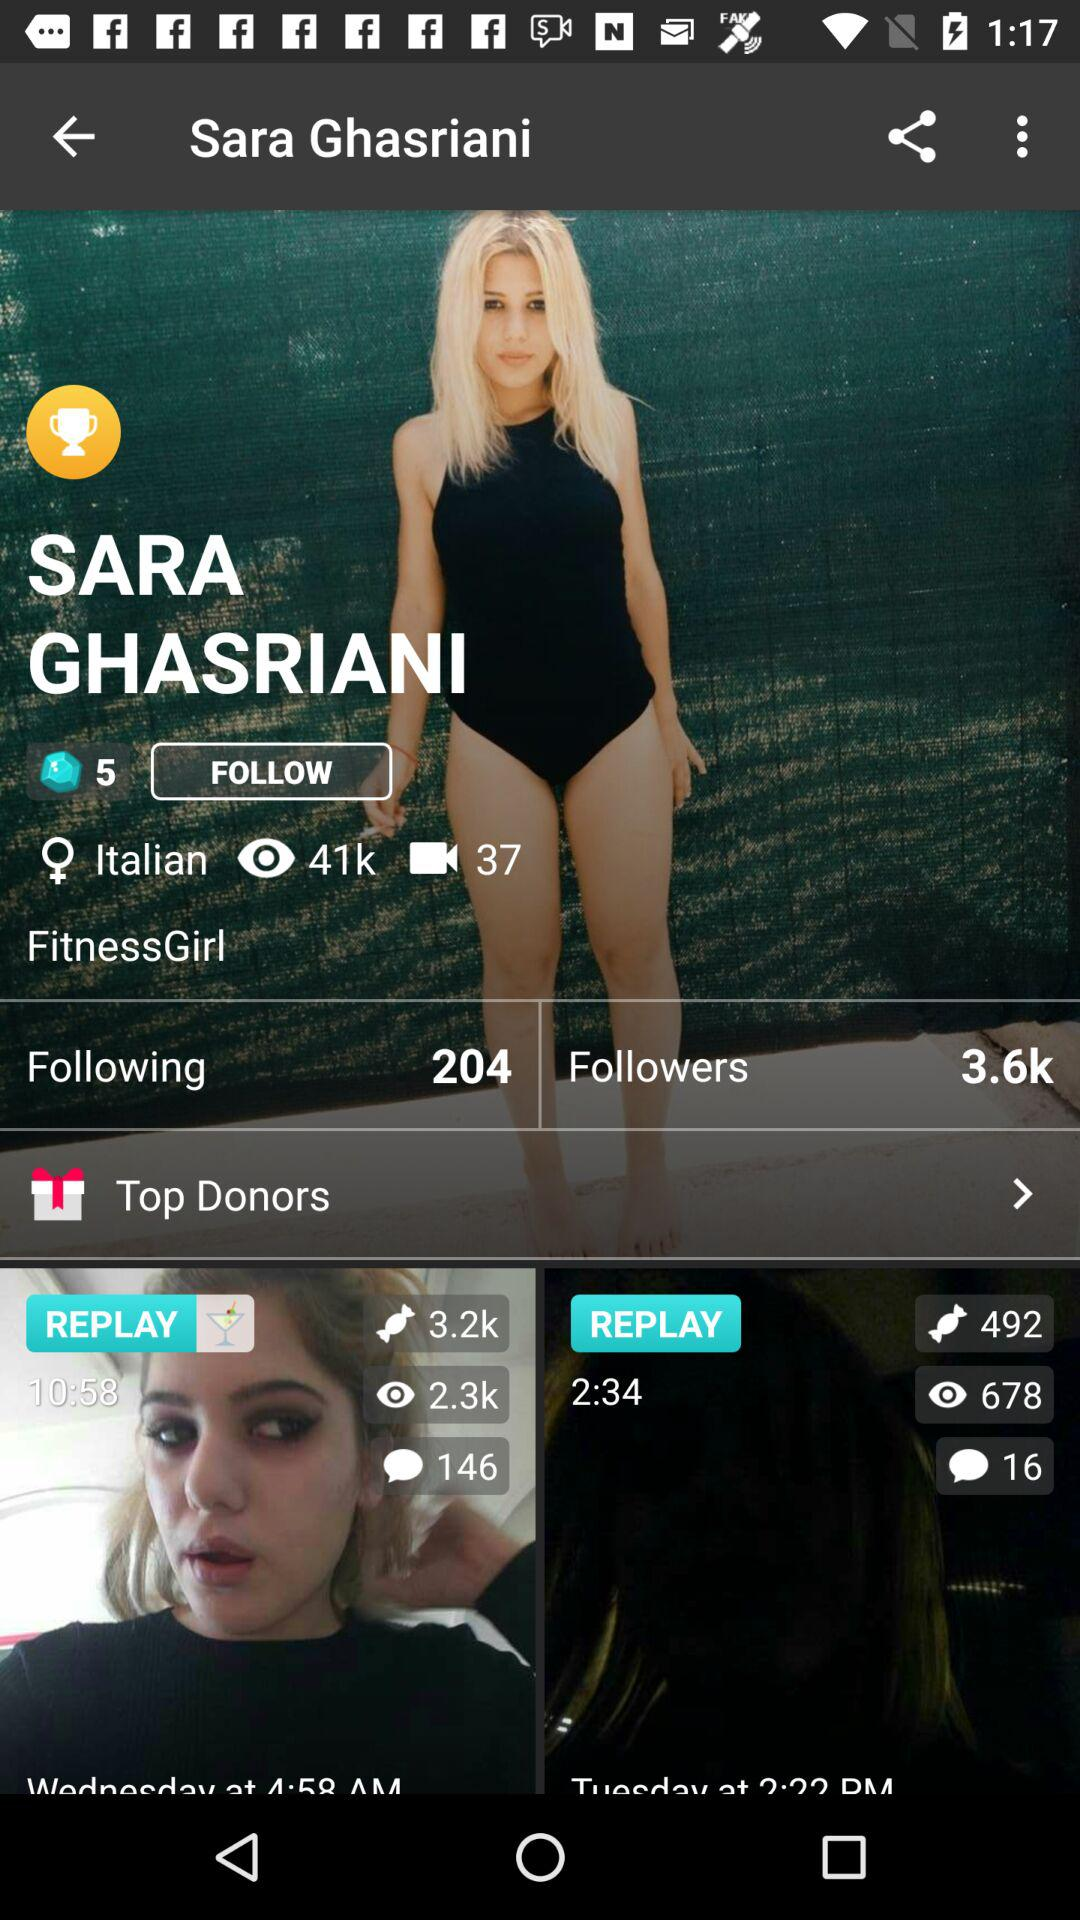How many people are followed by a user? The people that are followed by a user are 204. 